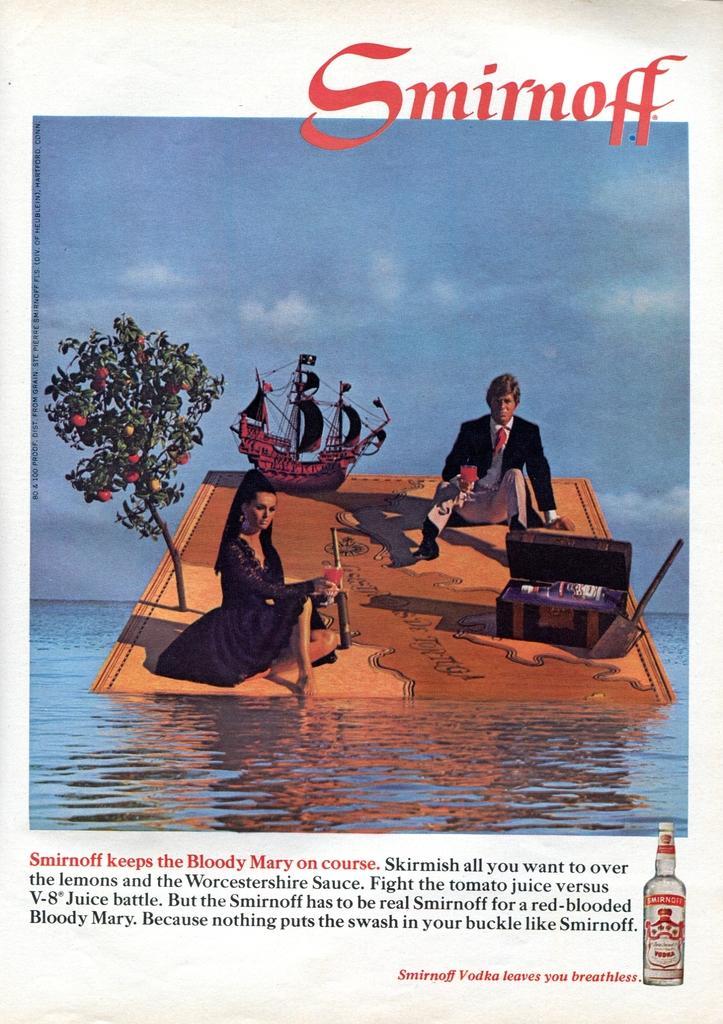Describe this image in one or two sentences. In this picture I can see a paper, there is a picture of two persons sitting on the wooden object, which is floating on the water, there is a tree, ship and there is a kind of a treasure box on the wooden object, and there are words on the paper. 